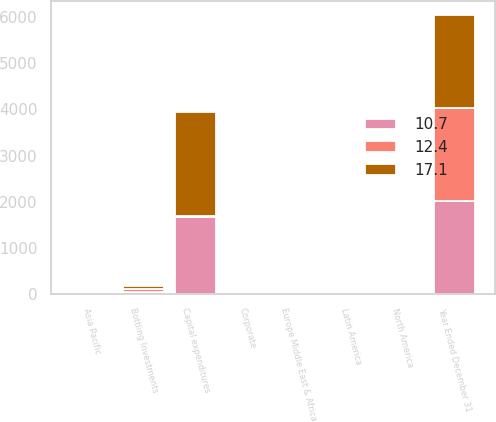<chart> <loc_0><loc_0><loc_500><loc_500><stacked_bar_chart><ecel><fcel>Year Ended December 31<fcel>Capital expenditures<fcel>Europe Middle East & Africa<fcel>Latin America<fcel>North America<fcel>Asia Pacific<fcel>Bottling Investments<fcel>Corporate<nl><fcel>10.7<fcel>2017<fcel>1675<fcel>4.8<fcel>3.3<fcel>32.3<fcel>3<fcel>39.5<fcel>17.1<nl><fcel>17.1<fcel>2016<fcel>2262<fcel>2.7<fcel>2<fcel>19.4<fcel>4.7<fcel>58.8<fcel>12.4<nl><fcel>12.4<fcel>2015<fcel>14.8<fcel>2.1<fcel>2.7<fcel>14.8<fcel>3.2<fcel>66.5<fcel>10.7<nl></chart> 